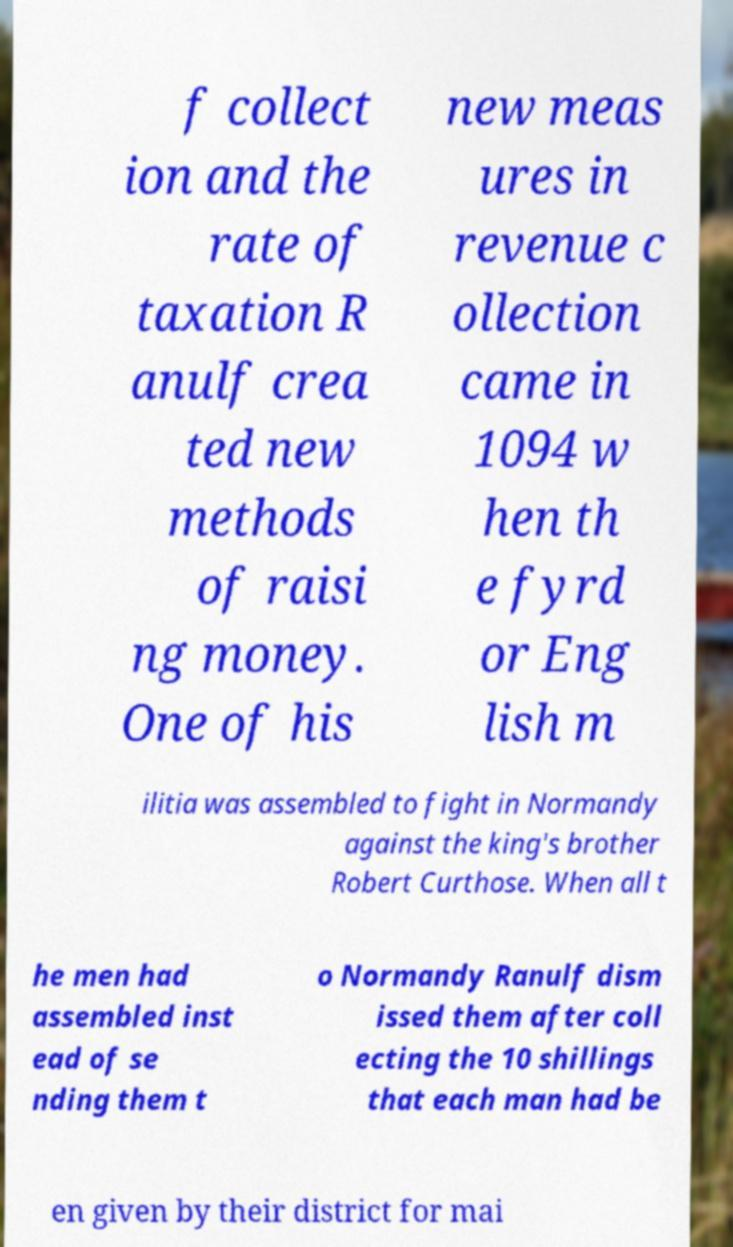There's text embedded in this image that I need extracted. Can you transcribe it verbatim? f collect ion and the rate of taxation R anulf crea ted new methods of raisi ng money. One of his new meas ures in revenue c ollection came in 1094 w hen th e fyrd or Eng lish m ilitia was assembled to fight in Normandy against the king's brother Robert Curthose. When all t he men had assembled inst ead of se nding them t o Normandy Ranulf dism issed them after coll ecting the 10 shillings that each man had be en given by their district for mai 